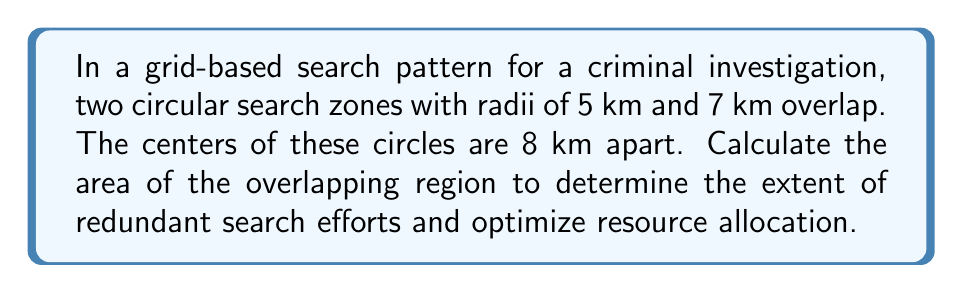Could you help me with this problem? To solve this problem, we'll use the formula for the area of intersection of two circles. Let's approach this step-by-step:

1) Let $r_1 = 5$ km (radius of first circle) and $r_2 = 7$ km (radius of second circle).
   The distance between centers, $d = 8$ km.

2) The formula for the area of intersection is:

   $$A = r_1^2 \arccos(\frac{d^2 + r_1^2 - r_2^2}{2dr_1}) + r_2^2 \arccos(\frac{d^2 + r_2^2 - r_1^2}{2dr_2}) - \frac{1}{2}\sqrt{(-d+r_1+r_2)(d+r_1-r_2)(d-r_1+r_2)(d+r_1+r_2)}$$

3) Let's calculate each part:

   a) $\frac{d^2 + r_1^2 - r_2^2}{2dr_1} = \frac{8^2 + 5^2 - 7^2}{2(8)(5)} = 0.34375$
   b) $\arccos(0.34375) = 1.2185$ radians
   c) $r_1^2 \arccos(\frac{d^2 + r_1^2 - r_2^2}{2dr_1}) = 5^2 * 1.2185 = 30.4625$

   d) $\frac{d^2 + r_2^2 - r_1^2}{2dr_2} = \frac{8^2 + 7^2 - 5^2}{2(8)(7)} = 0.71875$
   e) $\arccos(0.71875) = 0.7660$ radians
   f) $r_2^2 \arccos(\frac{d^2 + r_2^2 - r_1^2}{2dr_2}) = 7^2 * 0.7660 = 37.5340$

   g) $(-d+r_1+r_2)(d+r_1-r_2)(d-r_1+r_2)(d+r_1+r_2) = 4 * 6 * 10 * 20 = 4800$
   h) $\frac{1}{2}\sqrt{4800} = 34.6410$

4) Putting it all together:

   $A = 30.4625 + 37.5340 - 34.6410 = 33.3555$ sq km

[asy]
import geometry;

pair O1 = (0,0), O2 = (8,0);
real r1 = 5, r2 = 7;

draw(circle(O1, r1), rgb(0,0,1));
draw(circle(O2, r2), rgb(1,0,0));

draw(O1--O2, dashed);

label("5 km", O1, SW);
label("7 km", O2, SE);
label("8 km", (4,0), S);

dot("O1", O1, NW);
dot("O2", O2, NE);
[/asy]
Answer: $33.36$ sq km 